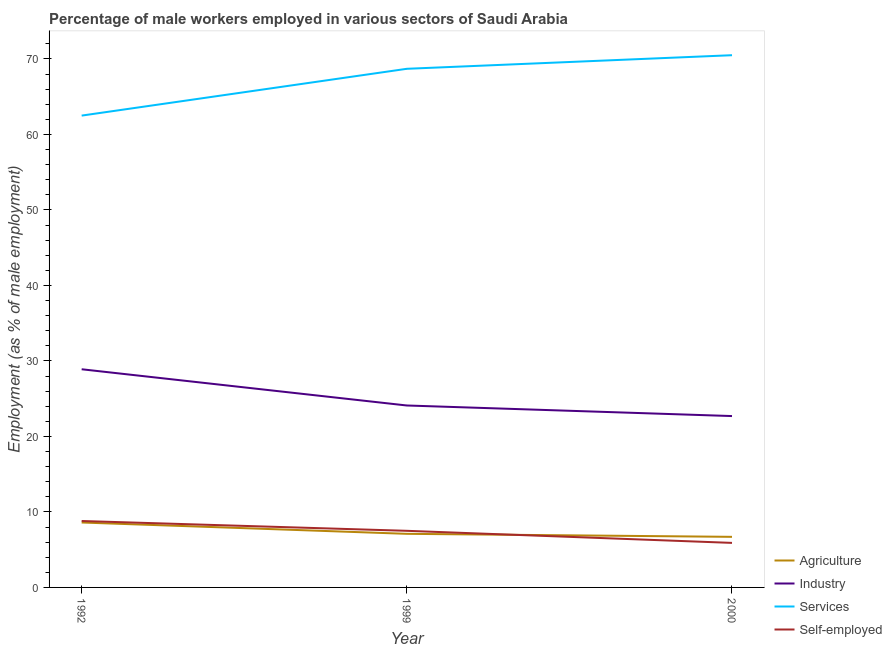How many different coloured lines are there?
Keep it short and to the point. 4. Does the line corresponding to percentage of male workers in agriculture intersect with the line corresponding to percentage of male workers in industry?
Offer a very short reply. No. Is the number of lines equal to the number of legend labels?
Make the answer very short. Yes. What is the percentage of male workers in services in 1999?
Your answer should be very brief. 68.7. Across all years, what is the maximum percentage of male workers in services?
Offer a very short reply. 70.5. Across all years, what is the minimum percentage of self employed male workers?
Offer a terse response. 5.9. In which year was the percentage of male workers in agriculture maximum?
Give a very brief answer. 1992. In which year was the percentage of male workers in industry minimum?
Offer a terse response. 2000. What is the total percentage of male workers in agriculture in the graph?
Provide a succinct answer. 22.4. What is the difference between the percentage of male workers in agriculture in 1992 and that in 1999?
Provide a short and direct response. 1.5. What is the difference between the percentage of self employed male workers in 1992 and the percentage of male workers in agriculture in 2000?
Give a very brief answer. 2.1. What is the average percentage of self employed male workers per year?
Make the answer very short. 7.4. In the year 1999, what is the difference between the percentage of male workers in industry and percentage of male workers in agriculture?
Your response must be concise. 17. What is the ratio of the percentage of male workers in industry in 1999 to that in 2000?
Keep it short and to the point. 1.06. Is the percentage of male workers in industry in 1999 less than that in 2000?
Keep it short and to the point. No. Is the difference between the percentage of self employed male workers in 1992 and 2000 greater than the difference between the percentage of male workers in agriculture in 1992 and 2000?
Offer a terse response. Yes. What is the difference between the highest and the second highest percentage of male workers in services?
Offer a terse response. 1.8. What is the difference between the highest and the lowest percentage of male workers in agriculture?
Your answer should be compact. 1.9. Is it the case that in every year, the sum of the percentage of male workers in industry and percentage of self employed male workers is greater than the sum of percentage of male workers in services and percentage of male workers in agriculture?
Offer a very short reply. Yes. Does the percentage of self employed male workers monotonically increase over the years?
Offer a very short reply. No. How many years are there in the graph?
Keep it short and to the point. 3. What is the difference between two consecutive major ticks on the Y-axis?
Offer a terse response. 10. Where does the legend appear in the graph?
Keep it short and to the point. Bottom right. How are the legend labels stacked?
Offer a terse response. Vertical. What is the title of the graph?
Ensure brevity in your answer.  Percentage of male workers employed in various sectors of Saudi Arabia. What is the label or title of the X-axis?
Offer a very short reply. Year. What is the label or title of the Y-axis?
Offer a terse response. Employment (as % of male employment). What is the Employment (as % of male employment) in Agriculture in 1992?
Offer a terse response. 8.6. What is the Employment (as % of male employment) of Industry in 1992?
Provide a succinct answer. 28.9. What is the Employment (as % of male employment) in Services in 1992?
Make the answer very short. 62.5. What is the Employment (as % of male employment) of Self-employed in 1992?
Keep it short and to the point. 8.8. What is the Employment (as % of male employment) of Agriculture in 1999?
Offer a terse response. 7.1. What is the Employment (as % of male employment) of Industry in 1999?
Offer a very short reply. 24.1. What is the Employment (as % of male employment) in Services in 1999?
Provide a short and direct response. 68.7. What is the Employment (as % of male employment) of Self-employed in 1999?
Offer a very short reply. 7.5. What is the Employment (as % of male employment) of Agriculture in 2000?
Your answer should be compact. 6.7. What is the Employment (as % of male employment) in Industry in 2000?
Give a very brief answer. 22.7. What is the Employment (as % of male employment) in Services in 2000?
Ensure brevity in your answer.  70.5. What is the Employment (as % of male employment) in Self-employed in 2000?
Offer a very short reply. 5.9. Across all years, what is the maximum Employment (as % of male employment) in Agriculture?
Provide a succinct answer. 8.6. Across all years, what is the maximum Employment (as % of male employment) of Industry?
Keep it short and to the point. 28.9. Across all years, what is the maximum Employment (as % of male employment) of Services?
Ensure brevity in your answer.  70.5. Across all years, what is the maximum Employment (as % of male employment) in Self-employed?
Provide a short and direct response. 8.8. Across all years, what is the minimum Employment (as % of male employment) of Agriculture?
Your response must be concise. 6.7. Across all years, what is the minimum Employment (as % of male employment) in Industry?
Provide a succinct answer. 22.7. Across all years, what is the minimum Employment (as % of male employment) of Services?
Your response must be concise. 62.5. Across all years, what is the minimum Employment (as % of male employment) in Self-employed?
Provide a short and direct response. 5.9. What is the total Employment (as % of male employment) of Agriculture in the graph?
Your response must be concise. 22.4. What is the total Employment (as % of male employment) in Industry in the graph?
Ensure brevity in your answer.  75.7. What is the total Employment (as % of male employment) of Services in the graph?
Offer a terse response. 201.7. What is the difference between the Employment (as % of male employment) of Agriculture in 1992 and that in 1999?
Provide a succinct answer. 1.5. What is the difference between the Employment (as % of male employment) of Services in 1992 and that in 1999?
Your response must be concise. -6.2. What is the difference between the Employment (as % of male employment) of Industry in 1999 and that in 2000?
Your answer should be compact. 1.4. What is the difference between the Employment (as % of male employment) of Agriculture in 1992 and the Employment (as % of male employment) of Industry in 1999?
Offer a very short reply. -15.5. What is the difference between the Employment (as % of male employment) of Agriculture in 1992 and the Employment (as % of male employment) of Services in 1999?
Provide a short and direct response. -60.1. What is the difference between the Employment (as % of male employment) in Agriculture in 1992 and the Employment (as % of male employment) in Self-employed in 1999?
Keep it short and to the point. 1.1. What is the difference between the Employment (as % of male employment) of Industry in 1992 and the Employment (as % of male employment) of Services in 1999?
Your answer should be very brief. -39.8. What is the difference between the Employment (as % of male employment) in Industry in 1992 and the Employment (as % of male employment) in Self-employed in 1999?
Provide a succinct answer. 21.4. What is the difference between the Employment (as % of male employment) of Services in 1992 and the Employment (as % of male employment) of Self-employed in 1999?
Your answer should be compact. 55. What is the difference between the Employment (as % of male employment) of Agriculture in 1992 and the Employment (as % of male employment) of Industry in 2000?
Your answer should be very brief. -14.1. What is the difference between the Employment (as % of male employment) in Agriculture in 1992 and the Employment (as % of male employment) in Services in 2000?
Provide a succinct answer. -61.9. What is the difference between the Employment (as % of male employment) in Industry in 1992 and the Employment (as % of male employment) in Services in 2000?
Your answer should be very brief. -41.6. What is the difference between the Employment (as % of male employment) of Services in 1992 and the Employment (as % of male employment) of Self-employed in 2000?
Your answer should be compact. 56.6. What is the difference between the Employment (as % of male employment) in Agriculture in 1999 and the Employment (as % of male employment) in Industry in 2000?
Provide a succinct answer. -15.6. What is the difference between the Employment (as % of male employment) of Agriculture in 1999 and the Employment (as % of male employment) of Services in 2000?
Provide a short and direct response. -63.4. What is the difference between the Employment (as % of male employment) of Agriculture in 1999 and the Employment (as % of male employment) of Self-employed in 2000?
Give a very brief answer. 1.2. What is the difference between the Employment (as % of male employment) of Industry in 1999 and the Employment (as % of male employment) of Services in 2000?
Offer a very short reply. -46.4. What is the difference between the Employment (as % of male employment) in Services in 1999 and the Employment (as % of male employment) in Self-employed in 2000?
Your response must be concise. 62.8. What is the average Employment (as % of male employment) in Agriculture per year?
Make the answer very short. 7.47. What is the average Employment (as % of male employment) in Industry per year?
Offer a terse response. 25.23. What is the average Employment (as % of male employment) in Services per year?
Offer a very short reply. 67.23. What is the average Employment (as % of male employment) of Self-employed per year?
Offer a very short reply. 7.4. In the year 1992, what is the difference between the Employment (as % of male employment) in Agriculture and Employment (as % of male employment) in Industry?
Ensure brevity in your answer.  -20.3. In the year 1992, what is the difference between the Employment (as % of male employment) in Agriculture and Employment (as % of male employment) in Services?
Offer a very short reply. -53.9. In the year 1992, what is the difference between the Employment (as % of male employment) in Industry and Employment (as % of male employment) in Services?
Offer a terse response. -33.6. In the year 1992, what is the difference between the Employment (as % of male employment) of Industry and Employment (as % of male employment) of Self-employed?
Your answer should be very brief. 20.1. In the year 1992, what is the difference between the Employment (as % of male employment) in Services and Employment (as % of male employment) in Self-employed?
Offer a terse response. 53.7. In the year 1999, what is the difference between the Employment (as % of male employment) of Agriculture and Employment (as % of male employment) of Industry?
Your answer should be compact. -17. In the year 1999, what is the difference between the Employment (as % of male employment) in Agriculture and Employment (as % of male employment) in Services?
Your answer should be compact. -61.6. In the year 1999, what is the difference between the Employment (as % of male employment) of Industry and Employment (as % of male employment) of Services?
Offer a terse response. -44.6. In the year 1999, what is the difference between the Employment (as % of male employment) of Services and Employment (as % of male employment) of Self-employed?
Offer a very short reply. 61.2. In the year 2000, what is the difference between the Employment (as % of male employment) of Agriculture and Employment (as % of male employment) of Industry?
Provide a short and direct response. -16. In the year 2000, what is the difference between the Employment (as % of male employment) in Agriculture and Employment (as % of male employment) in Services?
Provide a succinct answer. -63.8. In the year 2000, what is the difference between the Employment (as % of male employment) in Industry and Employment (as % of male employment) in Services?
Ensure brevity in your answer.  -47.8. In the year 2000, what is the difference between the Employment (as % of male employment) in Services and Employment (as % of male employment) in Self-employed?
Make the answer very short. 64.6. What is the ratio of the Employment (as % of male employment) in Agriculture in 1992 to that in 1999?
Ensure brevity in your answer.  1.21. What is the ratio of the Employment (as % of male employment) in Industry in 1992 to that in 1999?
Your answer should be very brief. 1.2. What is the ratio of the Employment (as % of male employment) of Services in 1992 to that in 1999?
Make the answer very short. 0.91. What is the ratio of the Employment (as % of male employment) of Self-employed in 1992 to that in 1999?
Offer a very short reply. 1.17. What is the ratio of the Employment (as % of male employment) of Agriculture in 1992 to that in 2000?
Offer a terse response. 1.28. What is the ratio of the Employment (as % of male employment) of Industry in 1992 to that in 2000?
Keep it short and to the point. 1.27. What is the ratio of the Employment (as % of male employment) of Services in 1992 to that in 2000?
Offer a terse response. 0.89. What is the ratio of the Employment (as % of male employment) of Self-employed in 1992 to that in 2000?
Offer a very short reply. 1.49. What is the ratio of the Employment (as % of male employment) of Agriculture in 1999 to that in 2000?
Your answer should be very brief. 1.06. What is the ratio of the Employment (as % of male employment) of Industry in 1999 to that in 2000?
Your answer should be compact. 1.06. What is the ratio of the Employment (as % of male employment) in Services in 1999 to that in 2000?
Your response must be concise. 0.97. What is the ratio of the Employment (as % of male employment) of Self-employed in 1999 to that in 2000?
Ensure brevity in your answer.  1.27. What is the difference between the highest and the lowest Employment (as % of male employment) of Services?
Offer a terse response. 8. 